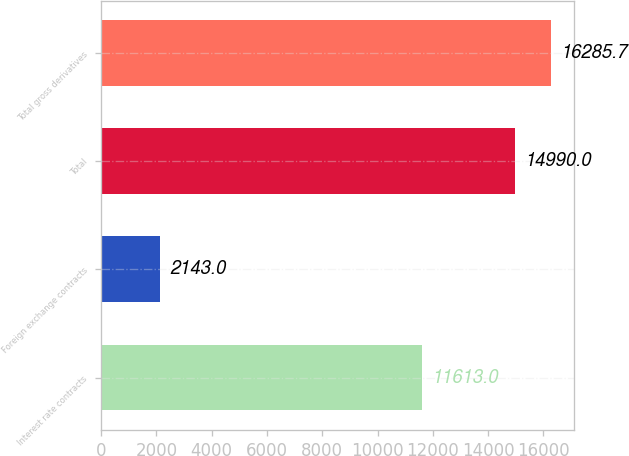<chart> <loc_0><loc_0><loc_500><loc_500><bar_chart><fcel>Interest rate contracts<fcel>Foreign exchange contracts<fcel>Total<fcel>Total gross derivatives<nl><fcel>11613<fcel>2143<fcel>14990<fcel>16285.7<nl></chart> 